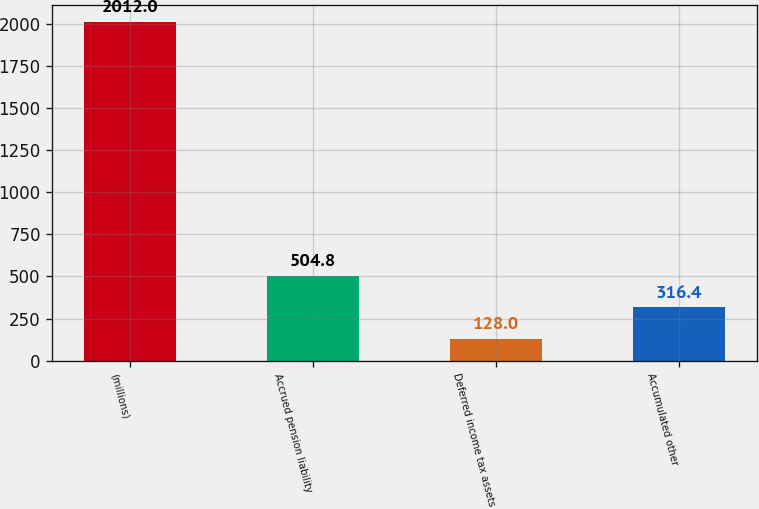Convert chart. <chart><loc_0><loc_0><loc_500><loc_500><bar_chart><fcel>(millions)<fcel>Accrued pension liability<fcel>Deferred income tax assets<fcel>Accumulated other<nl><fcel>2012<fcel>504.8<fcel>128<fcel>316.4<nl></chart> 